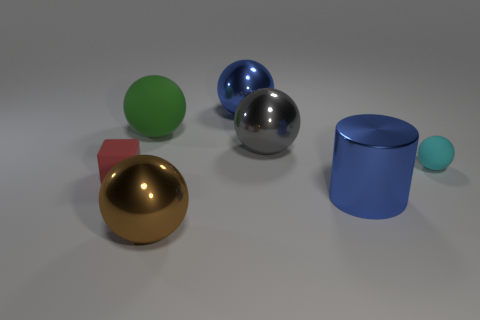What material is the brown ball?
Make the answer very short. Metal. How many cylinders are big purple matte things or big gray objects?
Offer a very short reply. 0. Do the large brown thing and the large gray object have the same material?
Provide a succinct answer. Yes. What size is the brown metallic thing that is the same shape as the big gray object?
Your answer should be very brief. Large. The large object that is both behind the tiny red object and in front of the big green thing is made of what material?
Ensure brevity in your answer.  Metal. Are there an equal number of red objects behind the red cube and gray rubber blocks?
Make the answer very short. Yes. How many things are shiny balls that are behind the brown ball or blue balls?
Offer a very short reply. 2. Does the big object that is behind the green thing have the same color as the cylinder?
Make the answer very short. Yes. There is a matte object right of the big cylinder; how big is it?
Make the answer very short. Small. What is the shape of the small rubber thing that is on the left side of the large blue thing that is to the right of the blue shiny sphere?
Ensure brevity in your answer.  Cube. 